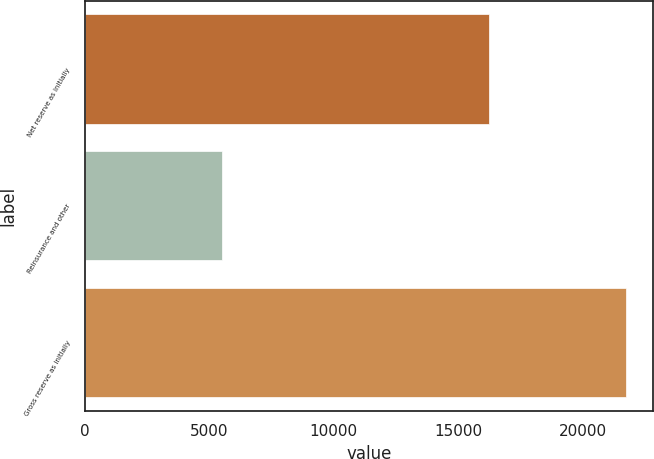Convert chart to OTSL. <chart><loc_0><loc_0><loc_500><loc_500><bar_chart><fcel>Net reserve as initially<fcel>Reinsurance and other<fcel>Gross reserve as initially<nl><fcel>16218<fcel>5497<fcel>21715<nl></chart> 